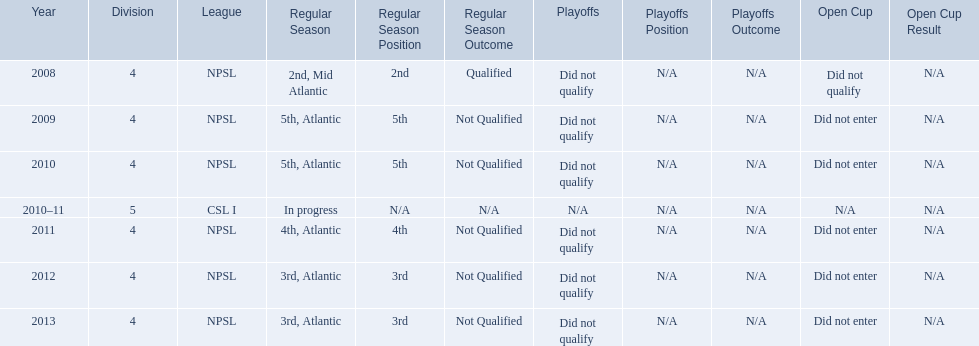What are all of the leagues? NPSL, NPSL, NPSL, CSL I, NPSL, NPSL, NPSL. Which league was played in the least? CSL I. 